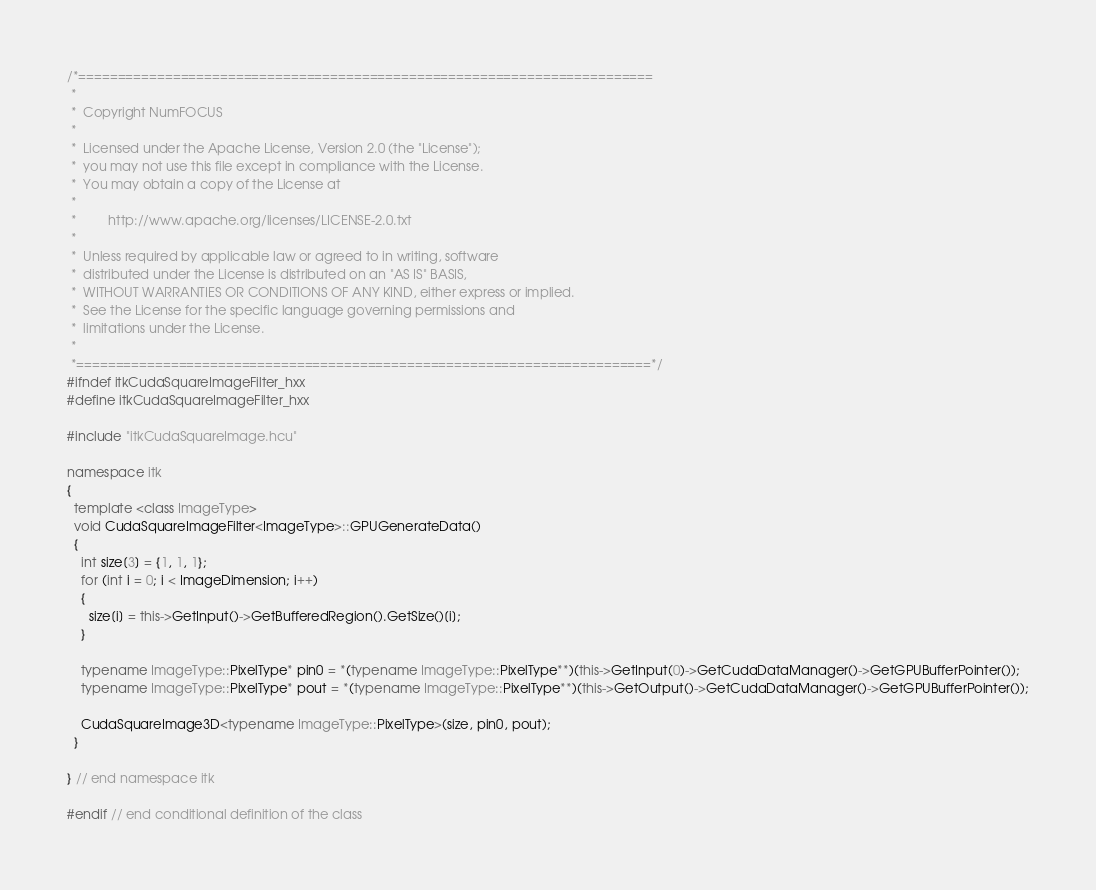Convert code to text. <code><loc_0><loc_0><loc_500><loc_500><_C++_>/*=========================================================================
 *
 *  Copyright NumFOCUS
 *
 *  Licensed under the Apache License, Version 2.0 (the "License");
 *  you may not use this file except in compliance with the License.
 *  You may obtain a copy of the License at
 *
 *         http://www.apache.org/licenses/LICENSE-2.0.txt
 *
 *  Unless required by applicable law or agreed to in writing, software
 *  distributed under the License is distributed on an "AS IS" BASIS,
 *  WITHOUT WARRANTIES OR CONDITIONS OF ANY KIND, either express or implied.
 *  See the License for the specific language governing permissions and
 *  limitations under the License.
 *
 *=========================================================================*/
#ifndef itkCudaSquareImageFilter_hxx
#define itkCudaSquareImageFilter_hxx

#include "itkCudaSquareImage.hcu"

namespace itk
{
  template <class ImageType>
  void CudaSquareImageFilter<ImageType>::GPUGenerateData()
  {
    int size[3] = {1, 1, 1};
    for (int i = 0; i < ImageDimension; i++)
    {
      size[i] = this->GetInput()->GetBufferedRegion().GetSize()[i];
    }

    typename ImageType::PixelType* pin0 = *(typename ImageType::PixelType**)(this->GetInput(0)->GetCudaDataManager()->GetGPUBufferPointer());
    typename ImageType::PixelType* pout = *(typename ImageType::PixelType**)(this->GetOutput()->GetCudaDataManager()->GetGPUBufferPointer());

    CudaSquareImage3D<typename ImageType::PixelType>(size, pin0, pout);
  }

} // end namespace itk

#endif // end conditional definition of the class
</code> 